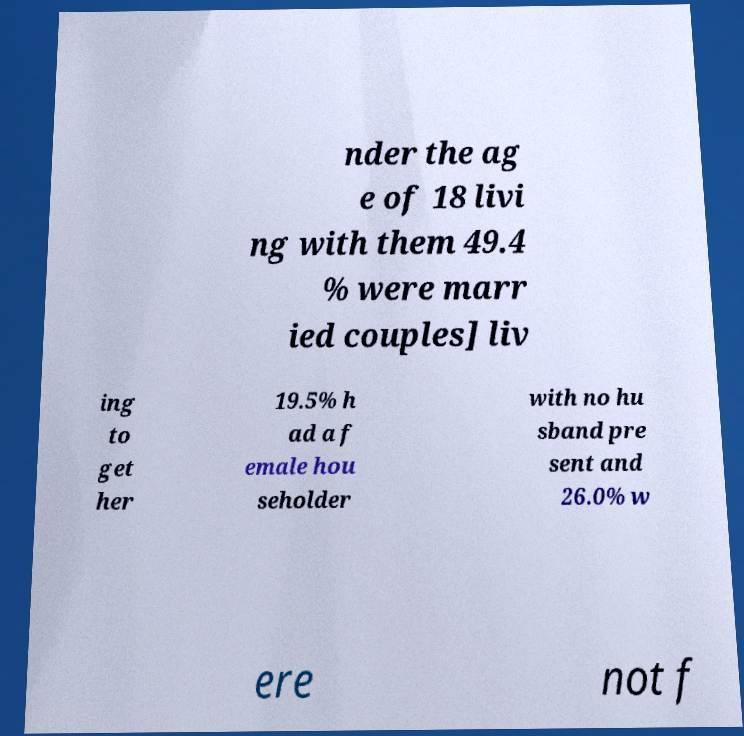What messages or text are displayed in this image? I need them in a readable, typed format. nder the ag e of 18 livi ng with them 49.4 % were marr ied couples] liv ing to get her 19.5% h ad a f emale hou seholder with no hu sband pre sent and 26.0% w ere not f 